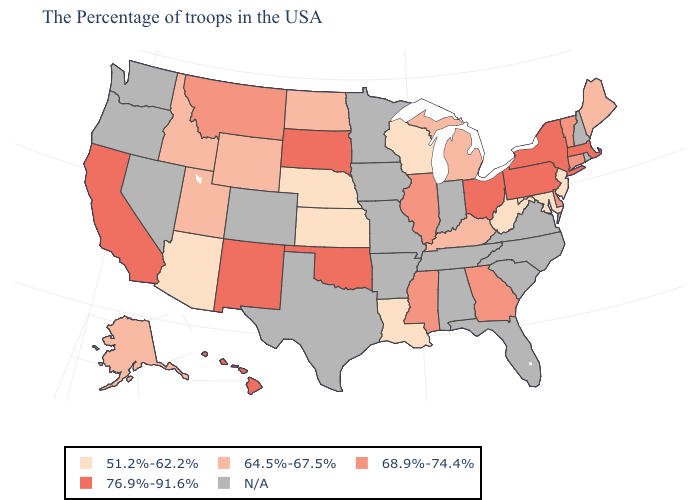Name the states that have a value in the range 51.2%-62.2%?
Keep it brief. New Jersey, Maryland, West Virginia, Wisconsin, Louisiana, Kansas, Nebraska, Arizona. What is the value of Kansas?
Keep it brief. 51.2%-62.2%. Name the states that have a value in the range 64.5%-67.5%?
Write a very short answer. Maine, Michigan, Kentucky, North Dakota, Wyoming, Utah, Idaho, Alaska. Name the states that have a value in the range 68.9%-74.4%?
Answer briefly. Vermont, Connecticut, Delaware, Georgia, Illinois, Mississippi, Montana. Which states have the lowest value in the USA?
Be succinct. New Jersey, Maryland, West Virginia, Wisconsin, Louisiana, Kansas, Nebraska, Arizona. What is the lowest value in the MidWest?
Keep it brief. 51.2%-62.2%. What is the highest value in the South ?
Quick response, please. 76.9%-91.6%. Does Nebraska have the lowest value in the USA?
Keep it brief. Yes. Name the states that have a value in the range 76.9%-91.6%?
Be succinct. Massachusetts, New York, Pennsylvania, Ohio, Oklahoma, South Dakota, New Mexico, California, Hawaii. Name the states that have a value in the range 51.2%-62.2%?
Keep it brief. New Jersey, Maryland, West Virginia, Wisconsin, Louisiana, Kansas, Nebraska, Arizona. What is the value of Maryland?
Be succinct. 51.2%-62.2%. Name the states that have a value in the range 64.5%-67.5%?
Concise answer only. Maine, Michigan, Kentucky, North Dakota, Wyoming, Utah, Idaho, Alaska. What is the value of Missouri?
Concise answer only. N/A. Name the states that have a value in the range 68.9%-74.4%?
Concise answer only. Vermont, Connecticut, Delaware, Georgia, Illinois, Mississippi, Montana. What is the value of Minnesota?
Be succinct. N/A. 